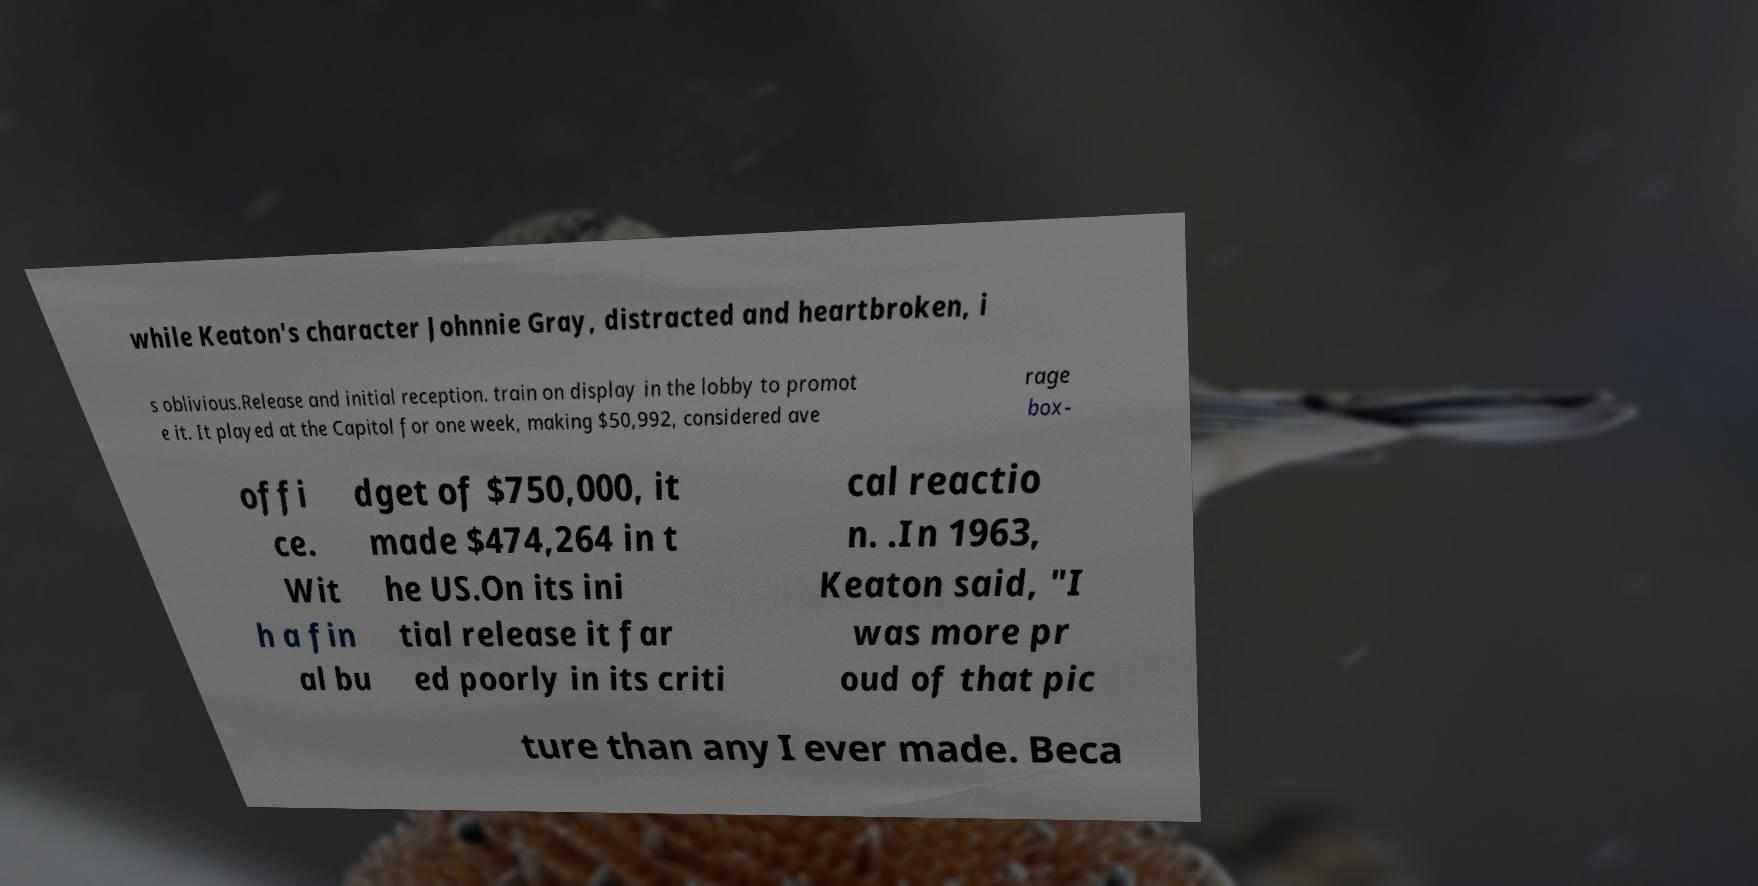What messages or text are displayed in this image? I need them in a readable, typed format. while Keaton's character Johnnie Gray, distracted and heartbroken, i s oblivious.Release and initial reception. train on display in the lobby to promot e it. It played at the Capitol for one week, making $50,992, considered ave rage box- offi ce. Wit h a fin al bu dget of $750,000, it made $474,264 in t he US.On its ini tial release it far ed poorly in its criti cal reactio n. .In 1963, Keaton said, "I was more pr oud of that pic ture than any I ever made. Beca 